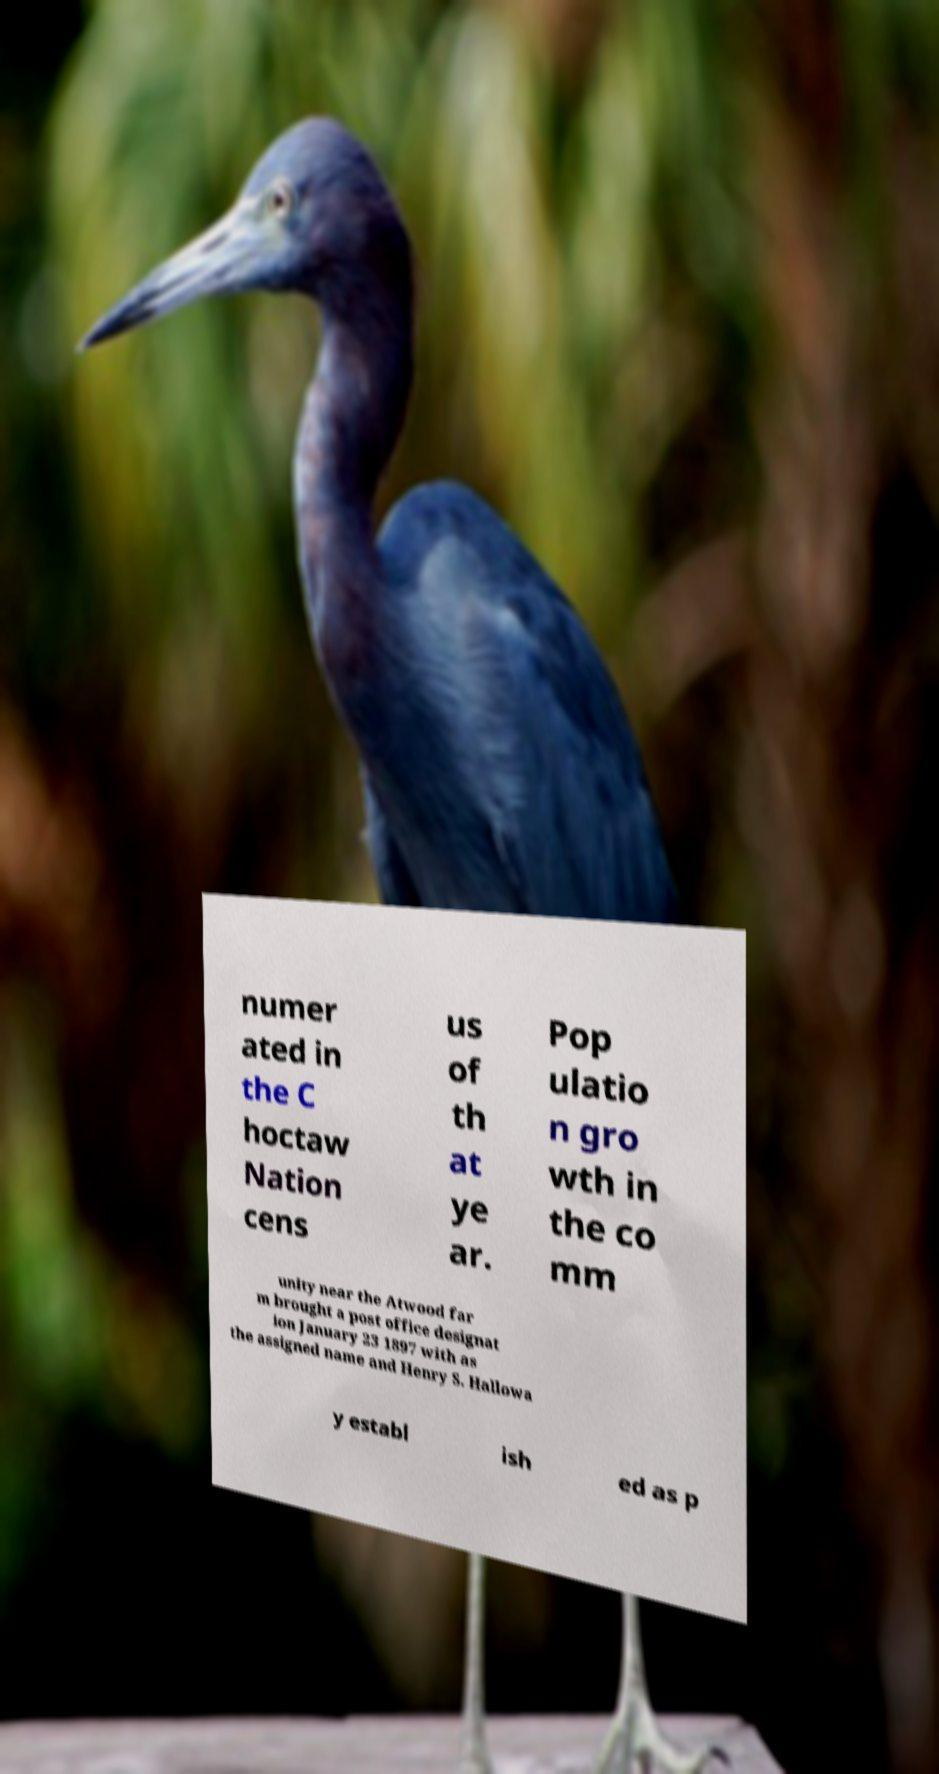Can you accurately transcribe the text from the provided image for me? numer ated in the C hoctaw Nation cens us of th at ye ar. Pop ulatio n gro wth in the co mm unity near the Atwood far m brought a post office designat ion January 23 1897 with as the assigned name and Henry S. Hallowa y establ ish ed as p 